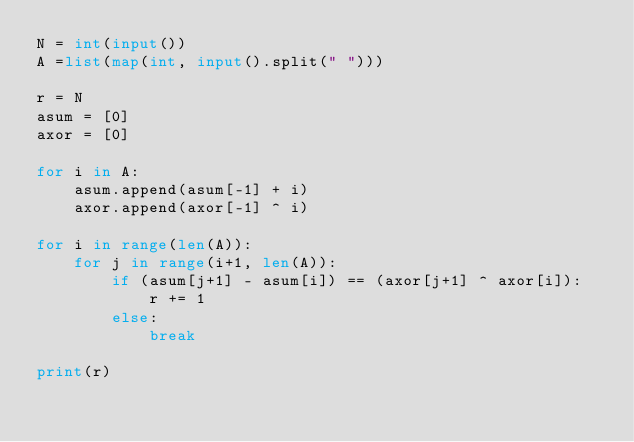Convert code to text. <code><loc_0><loc_0><loc_500><loc_500><_Python_>N = int(input())
A =list(map(int, input().split(" ")))

r = N
asum = [0]
axor = [0]

for i in A:
    asum.append(asum[-1] + i)
    axor.append(axor[-1] ^ i)

for i in range(len(A)):
    for j in range(i+1, len(A)):
        if (asum[j+1] - asum[i]) == (axor[j+1] ^ axor[i]):
            r += 1
        else:
            break

print(r)</code> 